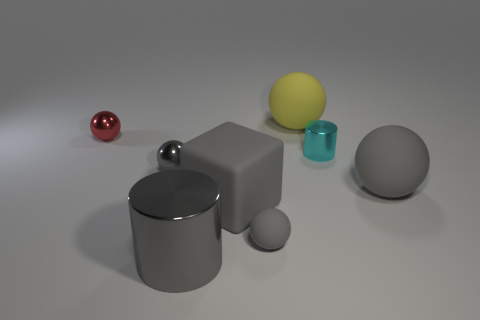Subtract all gray shiny spheres. How many spheres are left? 4 Subtract 4 balls. How many balls are left? 1 Add 2 brown rubber blocks. How many objects exist? 10 Subtract all yellow balls. How many balls are left? 4 Subtract all spheres. How many objects are left? 3 Add 8 large rubber cubes. How many large rubber cubes are left? 9 Add 6 big yellow objects. How many big yellow objects exist? 7 Subtract 0 brown spheres. How many objects are left? 8 Subtract all brown spheres. Subtract all purple blocks. How many spheres are left? 5 Subtract all yellow blocks. How many gray cylinders are left? 1 